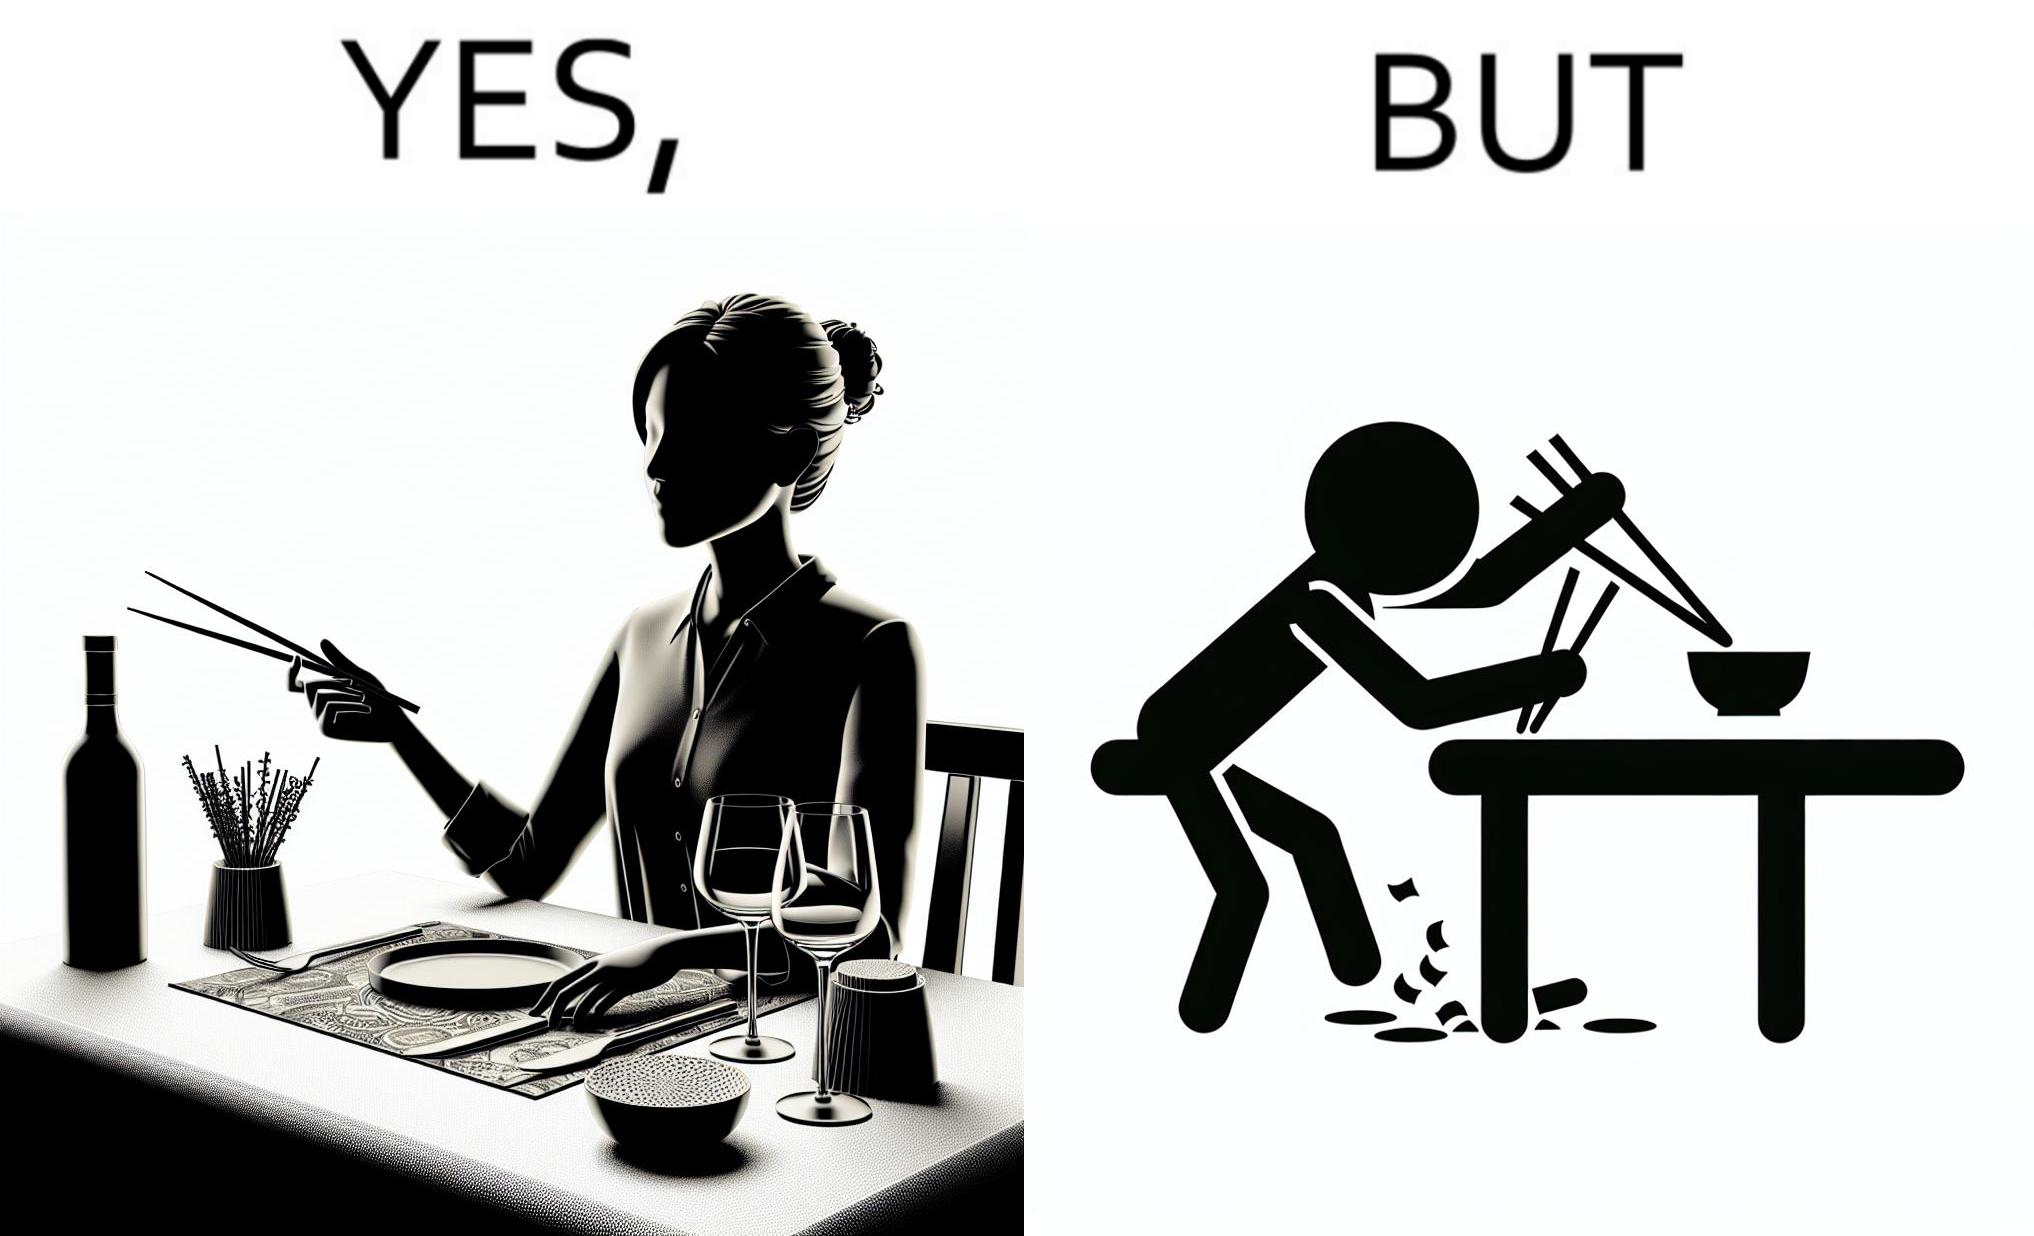What does this image depict? The image is satirical because even thought the woman is not able to eat food with chopstick properly, she chooses it over fork and knife to look sophisticaed. 